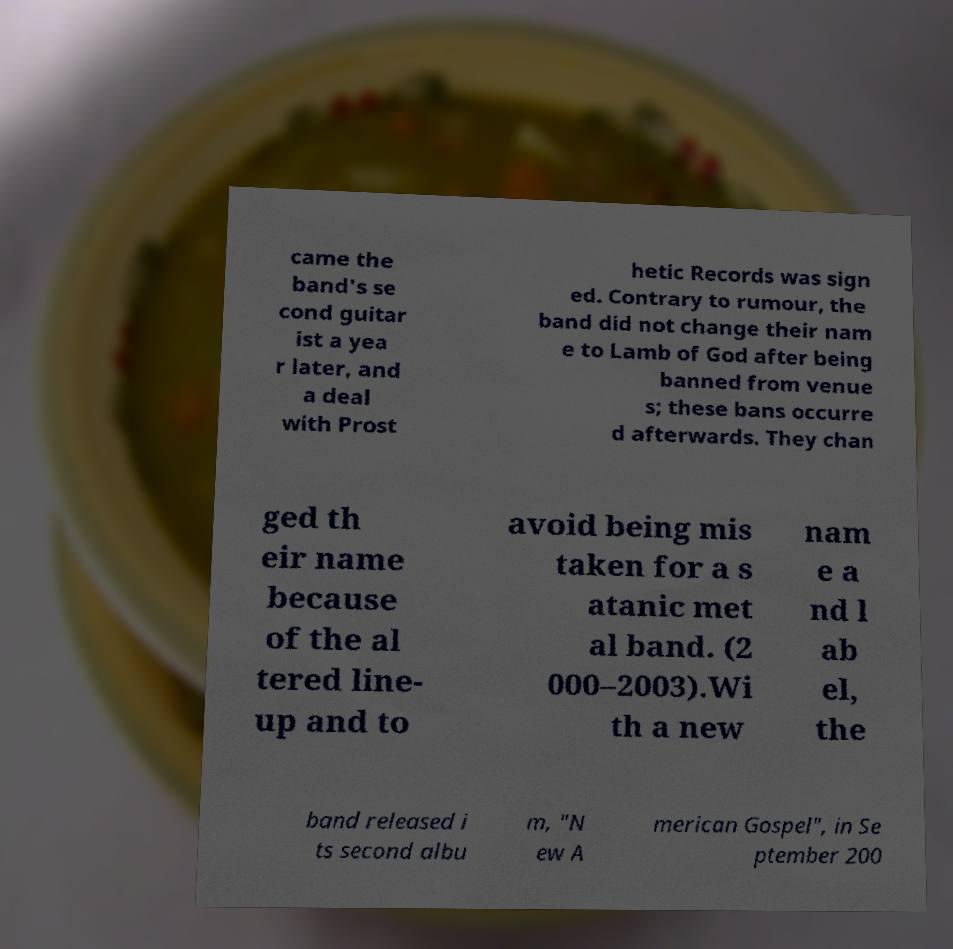There's text embedded in this image that I need extracted. Can you transcribe it verbatim? came the band's se cond guitar ist a yea r later, and a deal with Prost hetic Records was sign ed. Contrary to rumour, the band did not change their nam e to Lamb of God after being banned from venue s; these bans occurre d afterwards. They chan ged th eir name because of the al tered line- up and to avoid being mis taken for a s atanic met al band. (2 000–2003).Wi th a new nam e a nd l ab el, the band released i ts second albu m, "N ew A merican Gospel", in Se ptember 200 